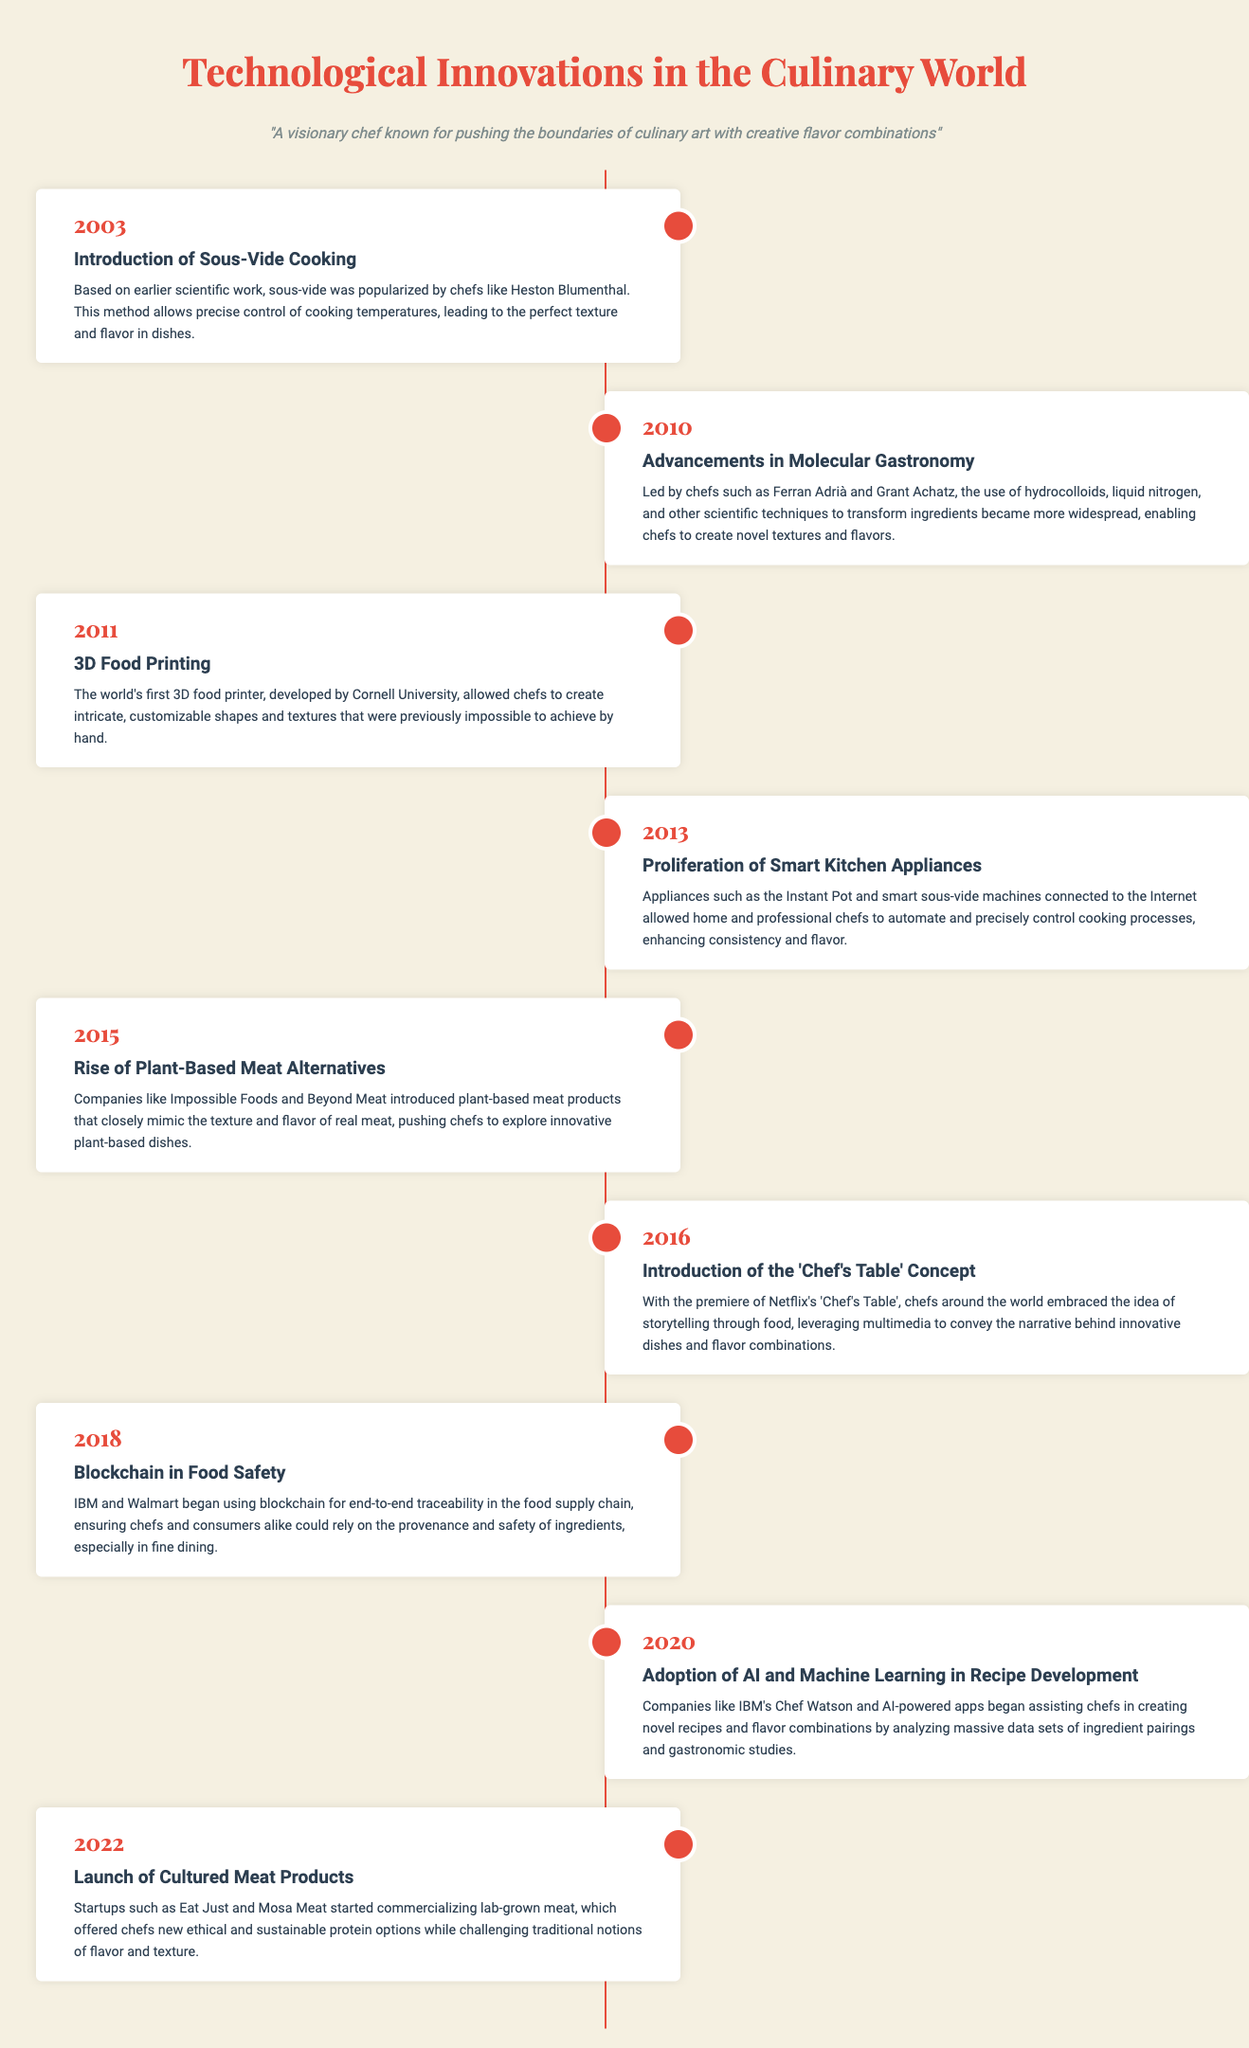What year was sous-vide cooking introduced? The document states that sous-vide cooking was introduced in the year 2003.
Answer: 2003 Who popularized sous-vide cooking? According to the timeline, chefs like Heston Blumenthal helped popularize sous-vide cooking.
Answer: Heston Blumenthal What significant culinary advancement occurred in 2010? The timeline indicates that advancements in molecular gastronomy occurred in 2010.
Answer: Advancements in molecular gastronomy What is the name of the world's first 3D food printer's developer? The document mentions that the world's first 3D food printer was developed by Cornell University.
Answer: Cornell University Which companies introduced plant-based meat alternatives in 2015? The document lists Impossible Foods and Beyond Meat as companies that introduced plant-based meat alternatives.
Answer: Impossible Foods and Beyond Meat What technological concept was launched in 2016 related to storytelling? The timeline indicates that the 'Chef's Table' concept was introduced in 2016.
Answer: 'Chef's Table' What was a notable trend related to AI in 2020? The timeline notes the adoption of AI and machine learning in recipe development as a notable trend in 2020.
Answer: AI and machine learning in recipe development Which year did the launch of cultured meat products occur? The document specifies that the launch of cultured meat products happened in 2022.
Answer: 2022 Which technology was used for food safety traceability in 2018? The document states that blockchain was utilized for food safety traceability that year.
Answer: Blockchain 